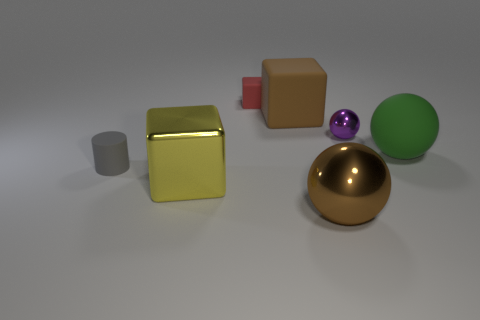Are there any small purple things left of the red rubber cube? no 